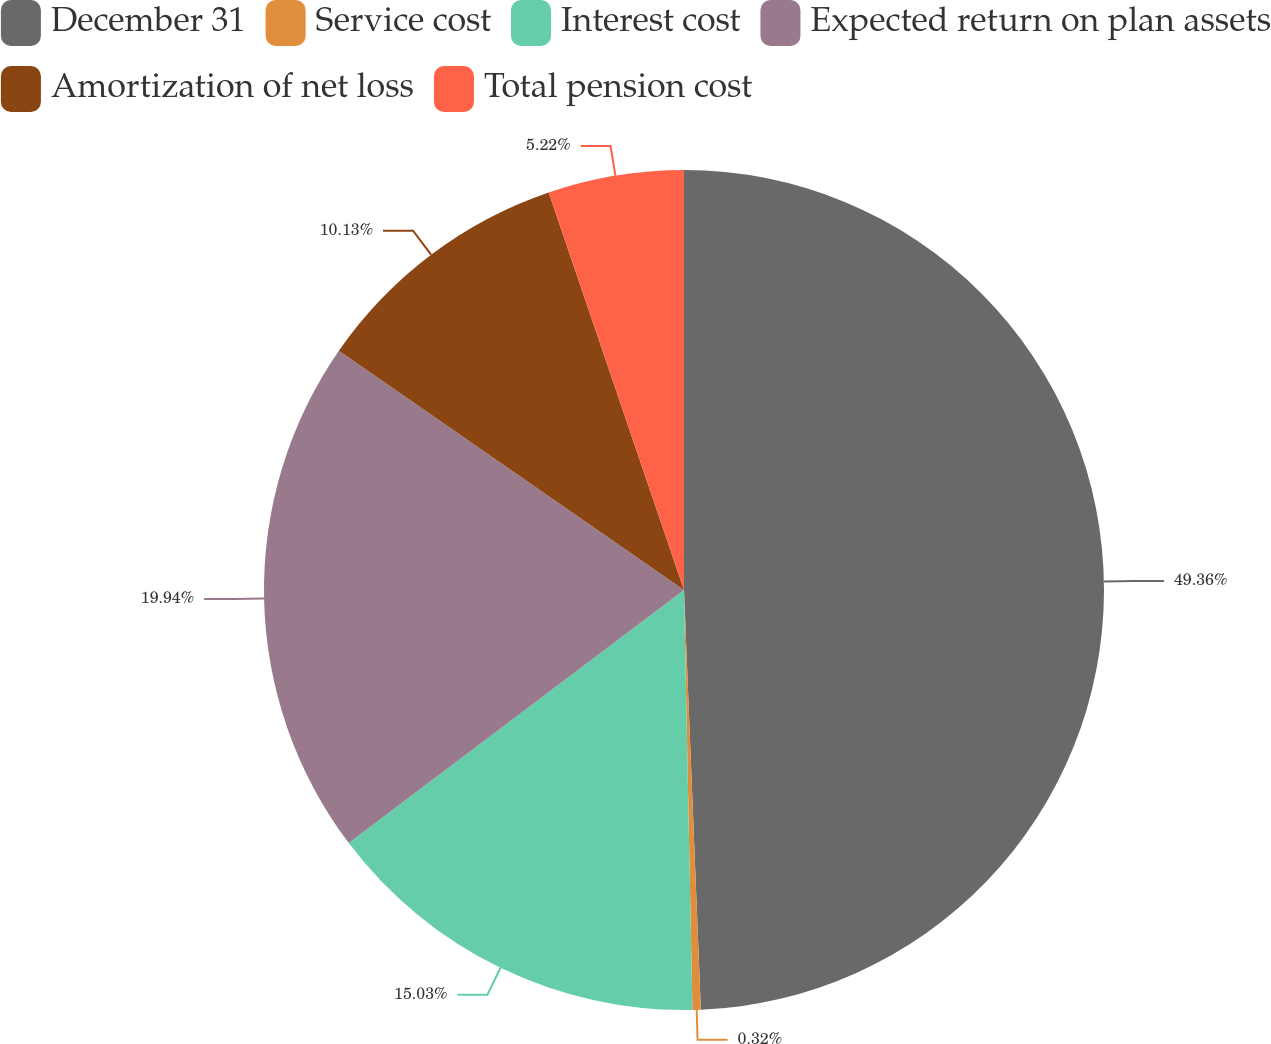Convert chart. <chart><loc_0><loc_0><loc_500><loc_500><pie_chart><fcel>December 31<fcel>Service cost<fcel>Interest cost<fcel>Expected return on plan assets<fcel>Amortization of net loss<fcel>Total pension cost<nl><fcel>49.36%<fcel>0.32%<fcel>15.03%<fcel>19.94%<fcel>10.13%<fcel>5.22%<nl></chart> 